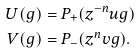Convert formula to latex. <formula><loc_0><loc_0><loc_500><loc_500>U ( g ) & = P _ { + } ( z ^ { - n } u g ) \\ V ( g ) & = P _ { - } ( z ^ { n } v g ) .</formula> 